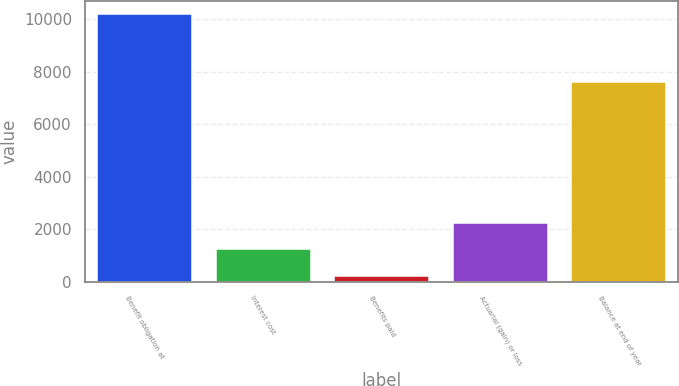<chart> <loc_0><loc_0><loc_500><loc_500><bar_chart><fcel>Benefit obligation at<fcel>Interest cost<fcel>Benefits paid<fcel>Actuarial (gain) or loss<fcel>Balance at end of year<nl><fcel>10193<fcel>1224.5<fcel>228<fcel>2221<fcel>7595<nl></chart> 